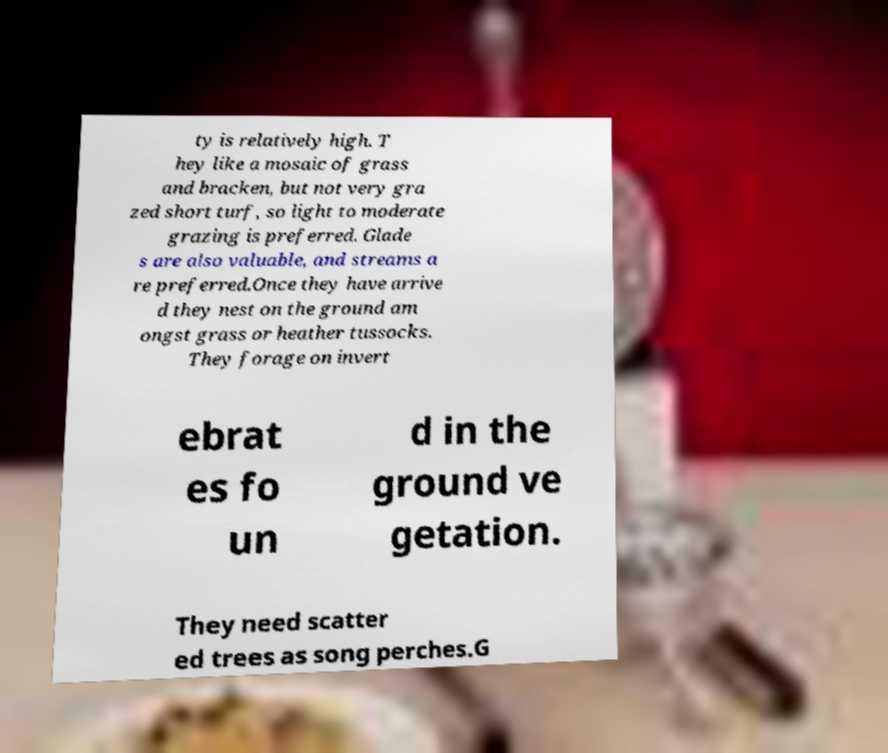Can you accurately transcribe the text from the provided image for me? ty is relatively high. T hey like a mosaic of grass and bracken, but not very gra zed short turf, so light to moderate grazing is preferred. Glade s are also valuable, and streams a re preferred.Once they have arrive d they nest on the ground am ongst grass or heather tussocks. They forage on invert ebrat es fo un d in the ground ve getation. They need scatter ed trees as song perches.G 